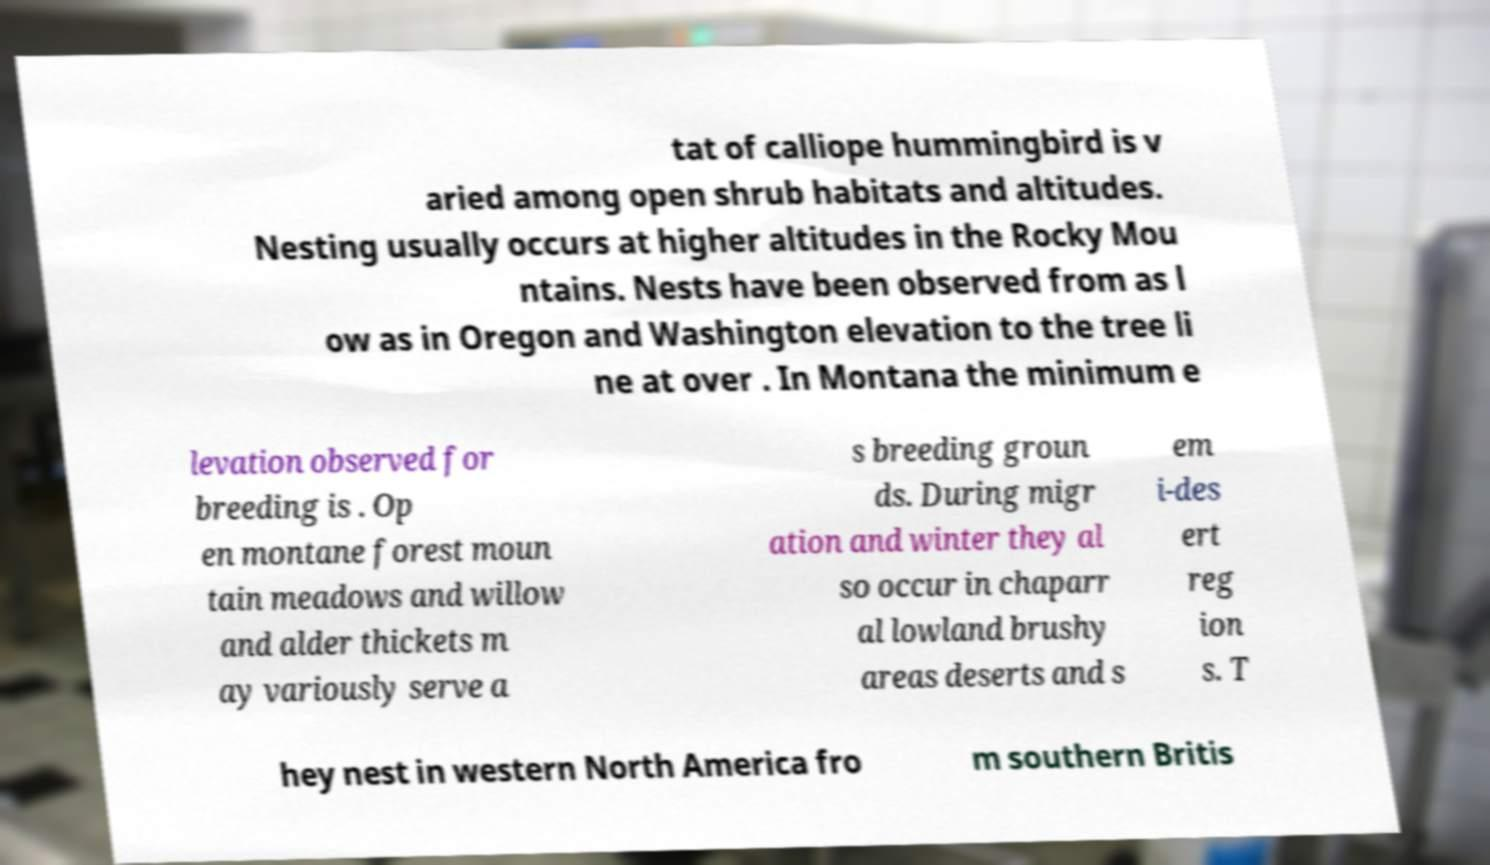What messages or text are displayed in this image? I need them in a readable, typed format. tat of calliope hummingbird is v aried among open shrub habitats and altitudes. Nesting usually occurs at higher altitudes in the Rocky Mou ntains. Nests have been observed from as l ow as in Oregon and Washington elevation to the tree li ne at over . In Montana the minimum e levation observed for breeding is . Op en montane forest moun tain meadows and willow and alder thickets m ay variously serve a s breeding groun ds. During migr ation and winter they al so occur in chaparr al lowland brushy areas deserts and s em i-des ert reg ion s. T hey nest in western North America fro m southern Britis 